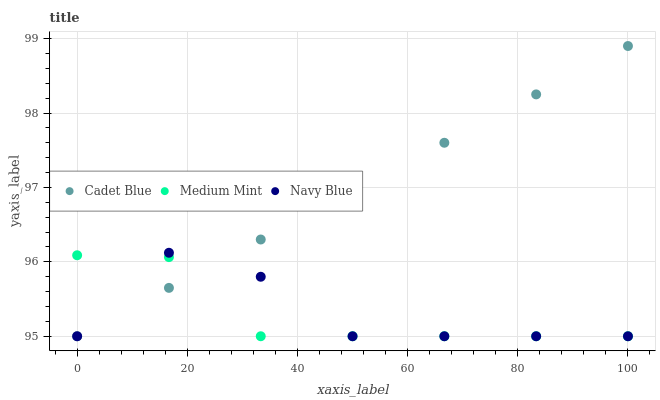Does Medium Mint have the minimum area under the curve?
Answer yes or no. Yes. Does Cadet Blue have the maximum area under the curve?
Answer yes or no. Yes. Does Navy Blue have the minimum area under the curve?
Answer yes or no. No. Does Navy Blue have the maximum area under the curve?
Answer yes or no. No. Is Cadet Blue the smoothest?
Answer yes or no. Yes. Is Navy Blue the roughest?
Answer yes or no. Yes. Is Navy Blue the smoothest?
Answer yes or no. No. Is Cadet Blue the roughest?
Answer yes or no. No. Does Medium Mint have the lowest value?
Answer yes or no. Yes. Does Cadet Blue have the highest value?
Answer yes or no. Yes. Does Navy Blue have the highest value?
Answer yes or no. No. Does Navy Blue intersect Cadet Blue?
Answer yes or no. Yes. Is Navy Blue less than Cadet Blue?
Answer yes or no. No. Is Navy Blue greater than Cadet Blue?
Answer yes or no. No. 